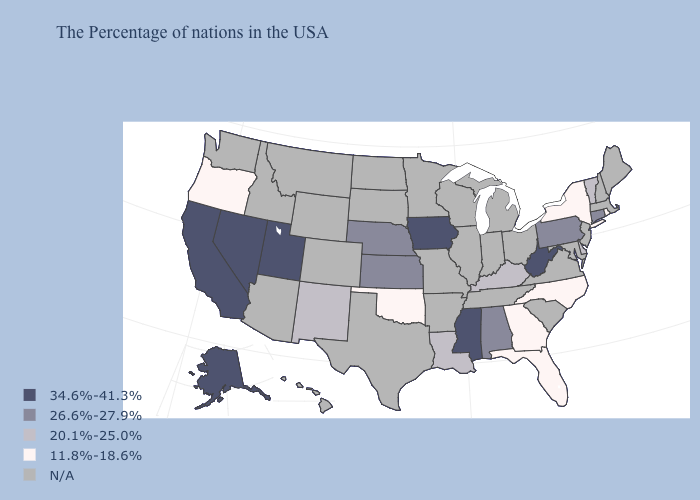Name the states that have a value in the range 26.6%-27.9%?
Keep it brief. Connecticut, Pennsylvania, Alabama, Kansas, Nebraska. How many symbols are there in the legend?
Write a very short answer. 5. Name the states that have a value in the range 26.6%-27.9%?
Write a very short answer. Connecticut, Pennsylvania, Alabama, Kansas, Nebraska. What is the value of Maine?
Answer briefly. N/A. What is the highest value in the West ?
Write a very short answer. 34.6%-41.3%. What is the value of Georgia?
Quick response, please. 11.8%-18.6%. Name the states that have a value in the range 20.1%-25.0%?
Short answer required. Vermont, Delaware, Kentucky, Louisiana, New Mexico. Which states hav the highest value in the Northeast?
Quick response, please. Connecticut, Pennsylvania. How many symbols are there in the legend?
Give a very brief answer. 5. Does Kansas have the highest value in the MidWest?
Keep it brief. No. How many symbols are there in the legend?
Be succinct. 5. Does the first symbol in the legend represent the smallest category?
Keep it brief. No. Name the states that have a value in the range 26.6%-27.9%?
Answer briefly. Connecticut, Pennsylvania, Alabama, Kansas, Nebraska. What is the value of Georgia?
Write a very short answer. 11.8%-18.6%. What is the value of Virginia?
Quick response, please. N/A. 